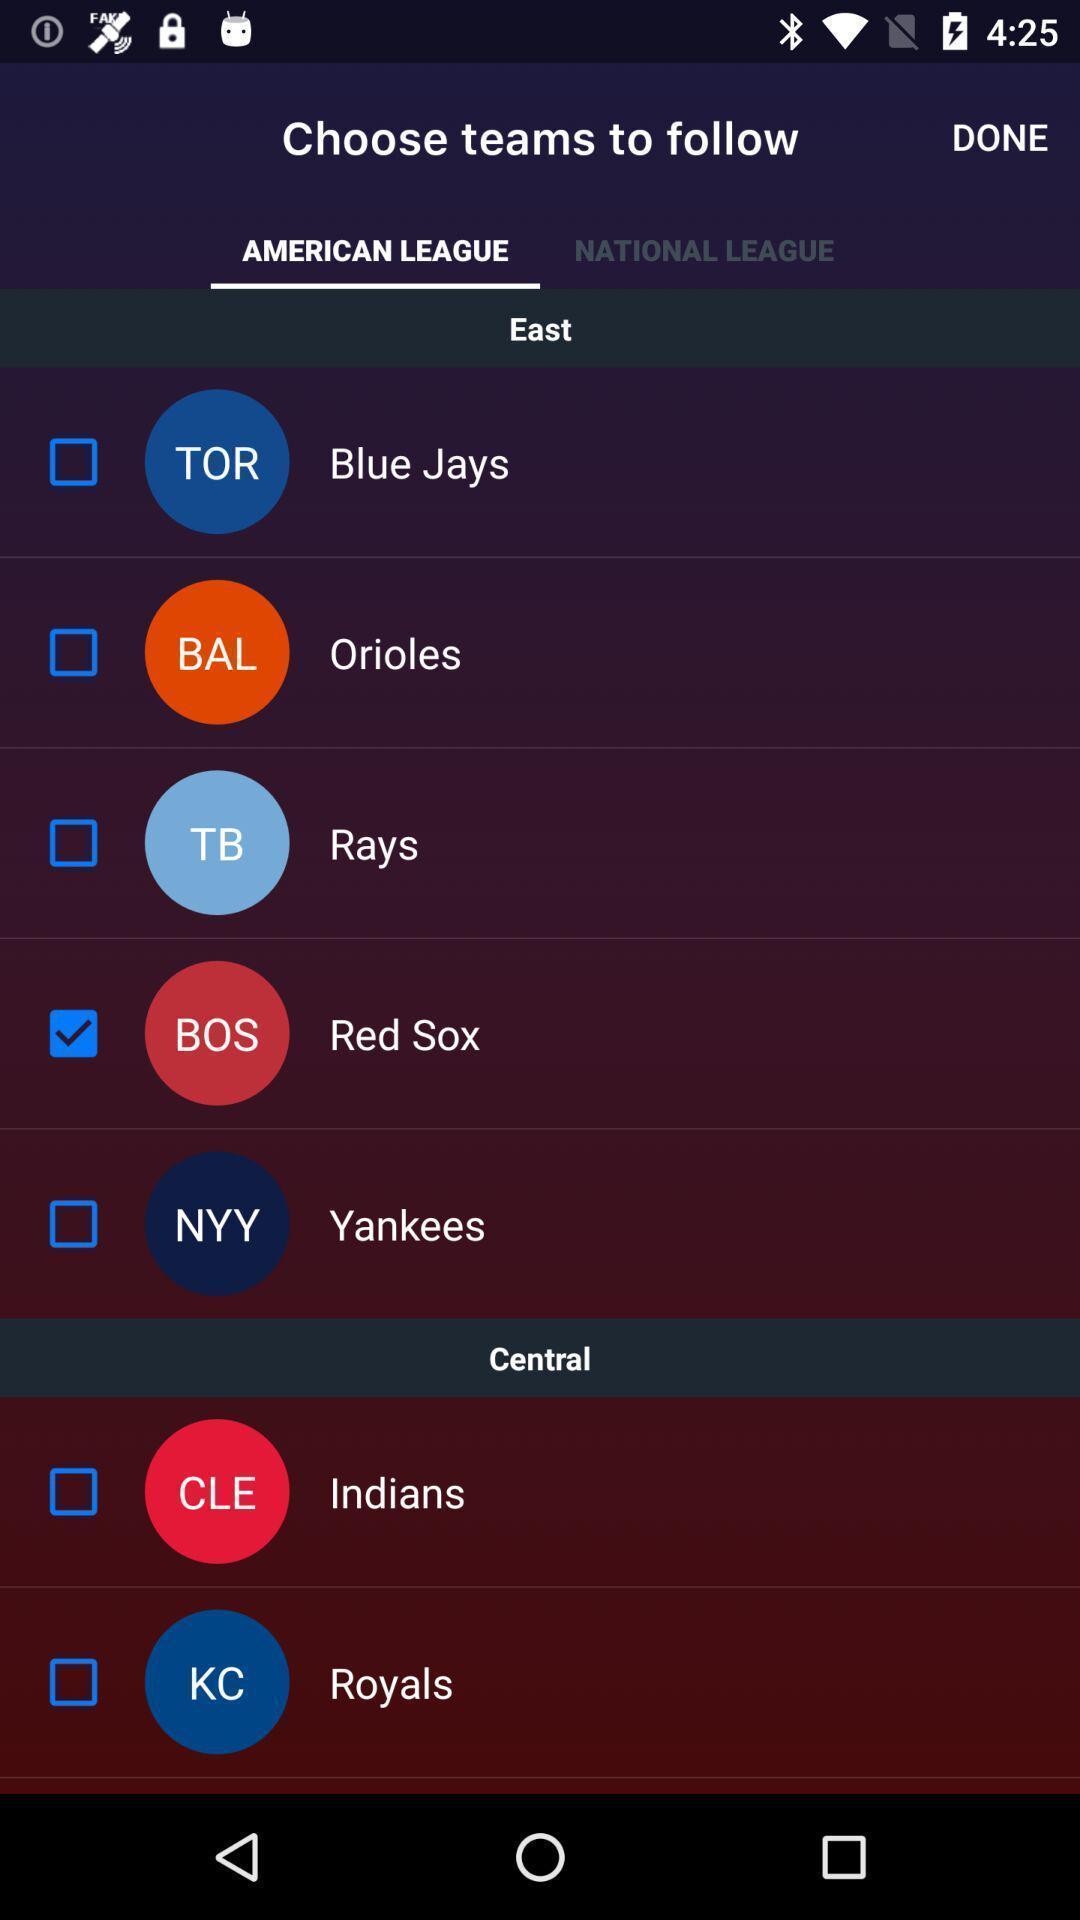Describe the content in this image. Screen displaying lists of teams. 